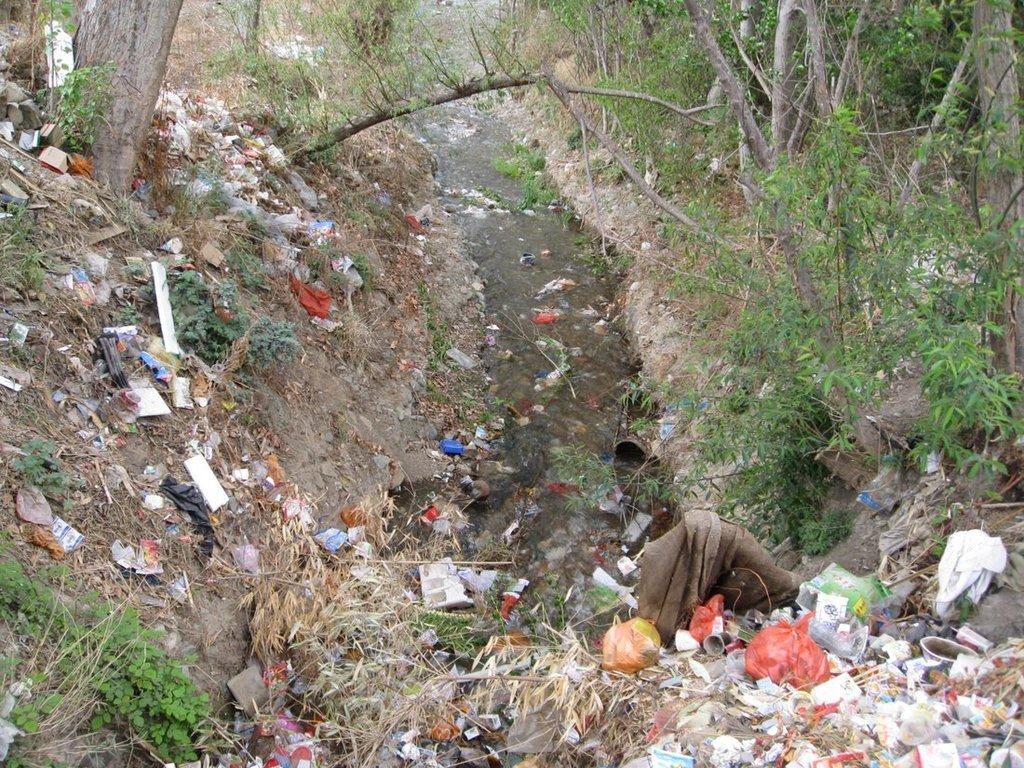What is placed on the ground in the image? There is trash placed on the ground. What can be seen in the background of the image? There is a group of trees and water visible in the background. What type of creature can be seen taking a test in the image? There is no creature present in the image, nor is there any indication of a test being taken. 